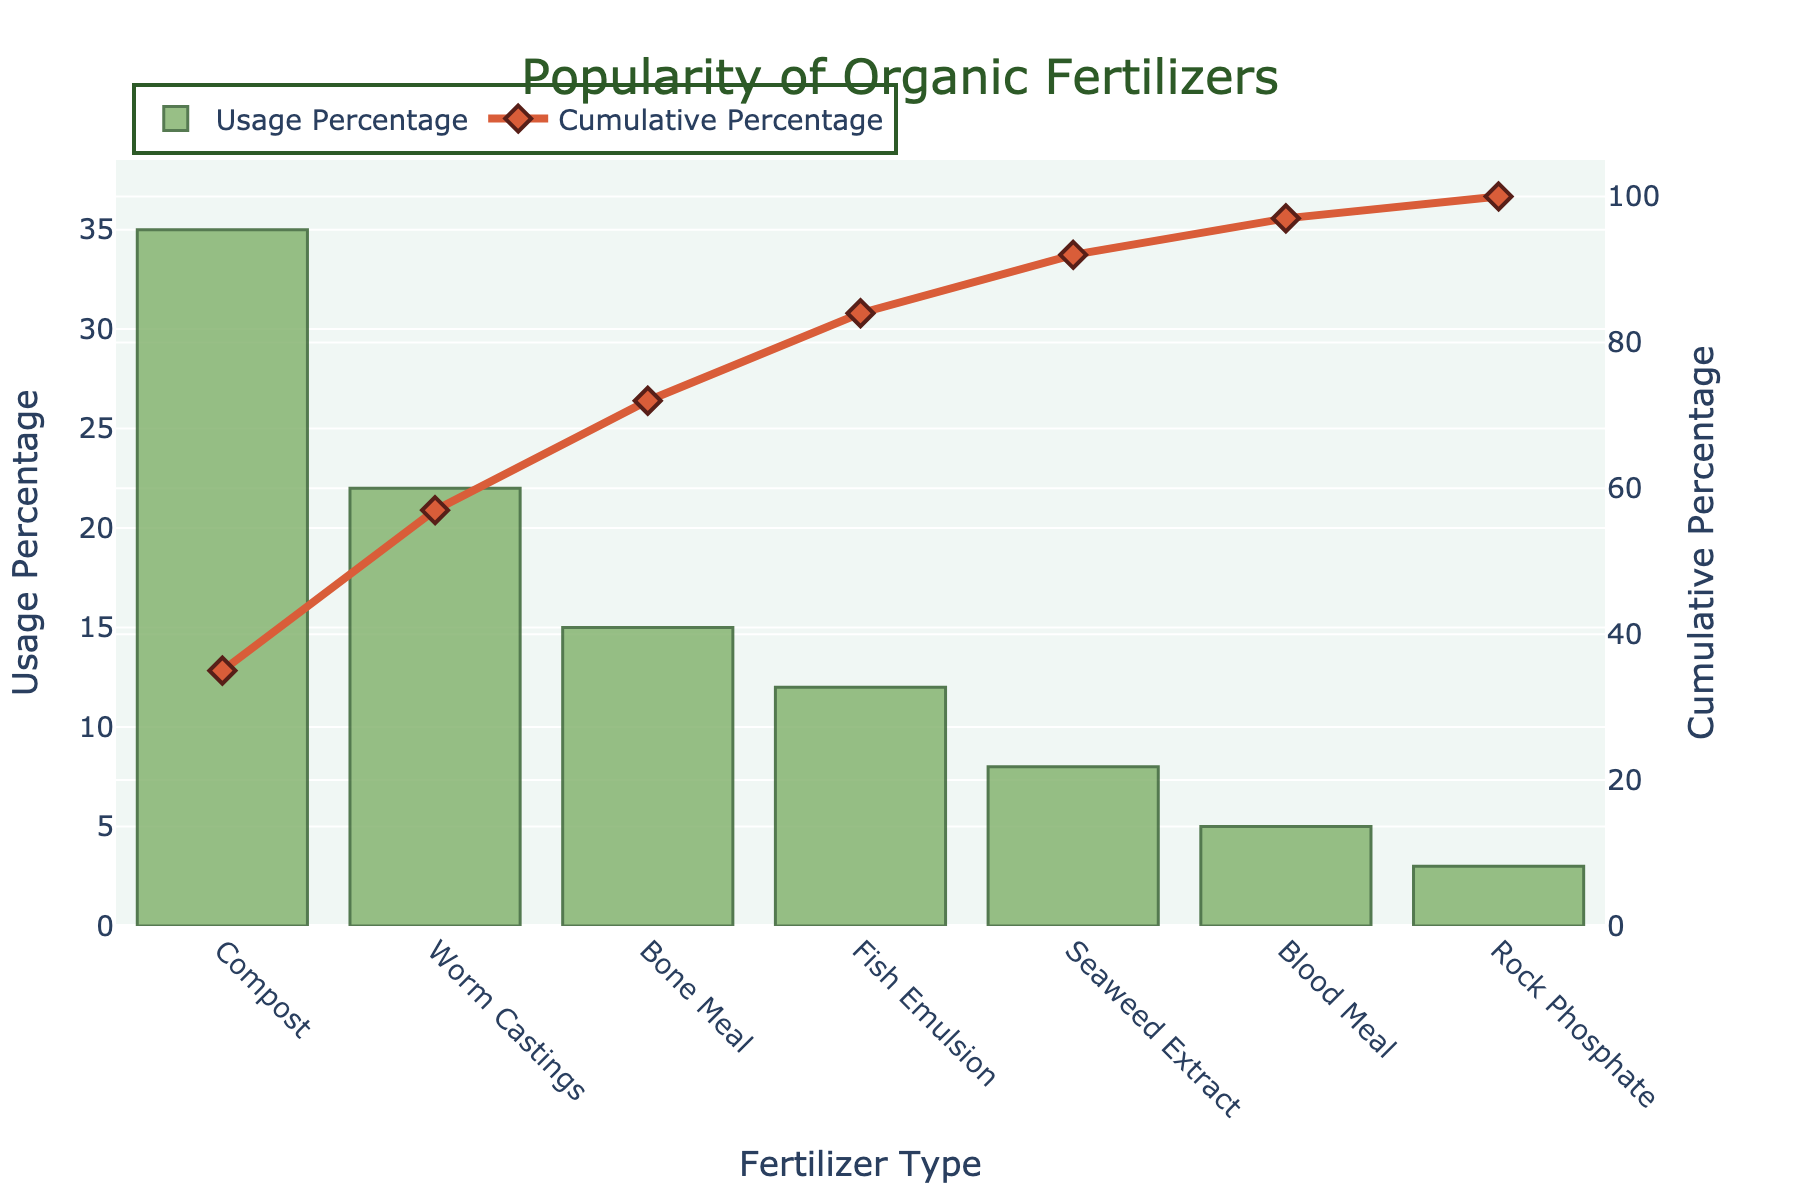What's the most popular organic fertilizer among the local community gardeners? The most popular organic fertilizer is the one with the highest usage percentage, which can be identified from the highest bar in the figure.
Answer: Compost What percentage of local community gardeners use Worm Castings? Locate the bar representing Worm Castings on the x-axis and read its corresponding height on the y-axis labeled "Usage Percentage."
Answer: 22% What is the cumulative percentage after adding the usage of Compost and Worm Castings? First, find the usage percentages of Compost (35%) and Worm Castings (22%). Sum these to get the cumulative percentage: 35% + 22% = 57%.
Answer: 57% Which fertilizer type has a usage percentage of 8%? Locate the bar with a height corresponding to 8% on the y-axis labeled "Usage Percentage" and identify the fertilizer type on the x-axis below it.
Answer: Seaweed Extract How much higher is the Usage Percentage of Compost compared to Bone Meal? Subtract the usage percentage of Bone Meal (15%) from the usage percentage of Compost (35%): 35% - 15% = 20%.
Answer: 20% What is the cumulative percentage at the point where Fish Emulsion is added? The cumulative percentage after Fish Emulsion is the sum of the percentages of Compost (35%), Worm Castings (22%), Bone Meal (15%), and Fish Emulsion (12%): 35% + 22% + 15% + 12% = 84%.
Answer: 84% Compare the usage of Blood Meal and Rock Phosphate. Which one is used more and by how much? Find the usage percentages for Blood Meal (5%) and Rock Phosphate (3%). Blood Meal is used more by 5% - 3% = 2%.
Answer: Blood Meal, 2% What trend does the Cumulative Percentage line show as we move from left to right? The cumulative percentage line increases as we move from left to right, indicating that the total percentage of gardeners using the fertilizers accumulates with each additional type.
Answer: Increasing How does the usage of Seaweed Extract (8%) compare with the cumulative percentage at Blood Meal (5%)? Seaweed Extract is 3% higher than Blood Meal on the "Usage Percentage" axis. However, we need to check the cumulative percentage line, which is rising from left to right. Blood Meal (5%) contributes to a cumulative percentage beyond 75%.
Answer: Seaweed Extract is higher by 3% in Usage Percentage, but the cumulative percentage accumulates How many types of fertilizers are represented in the chart? Count the number of distinct bars (or fertilizer types) on the x-axis. There are 7 types listed.
Answer: 7 